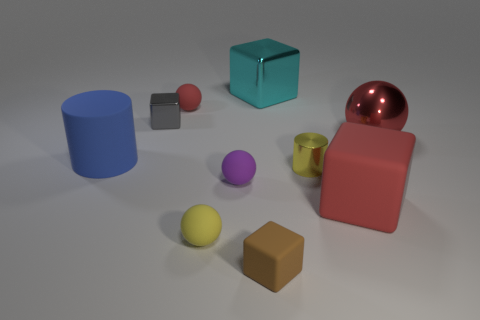Subtract all small rubber balls. How many balls are left? 1 Subtract all red blocks. How many blocks are left? 3 Subtract all cyan spheres. Subtract all red cylinders. How many spheres are left? 4 Subtract all cylinders. How many objects are left? 8 Add 3 small green rubber objects. How many small green rubber objects exist? 3 Subtract 0 yellow cubes. How many objects are left? 10 Subtract all large green rubber blocks. Subtract all big cyan shiny cubes. How many objects are left? 9 Add 9 tiny red matte objects. How many tiny red matte objects are left? 10 